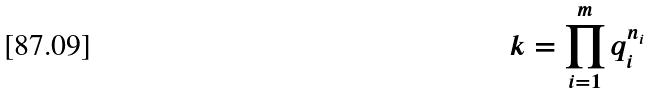<formula> <loc_0><loc_0><loc_500><loc_500>k = \prod _ { i = 1 } ^ { m } q _ { i } ^ { n _ { i } }</formula> 